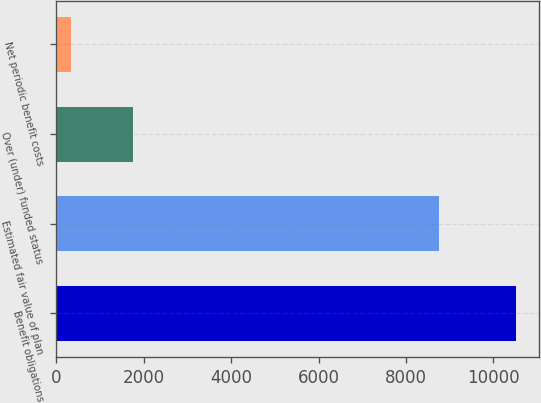<chart> <loc_0><loc_0><loc_500><loc_500><bar_chart><fcel>Benefit obligations<fcel>Estimated fair value of plan<fcel>Over (under) funded status<fcel>Net periodic benefit costs<nl><fcel>10506<fcel>8751<fcel>1755<fcel>346<nl></chart> 